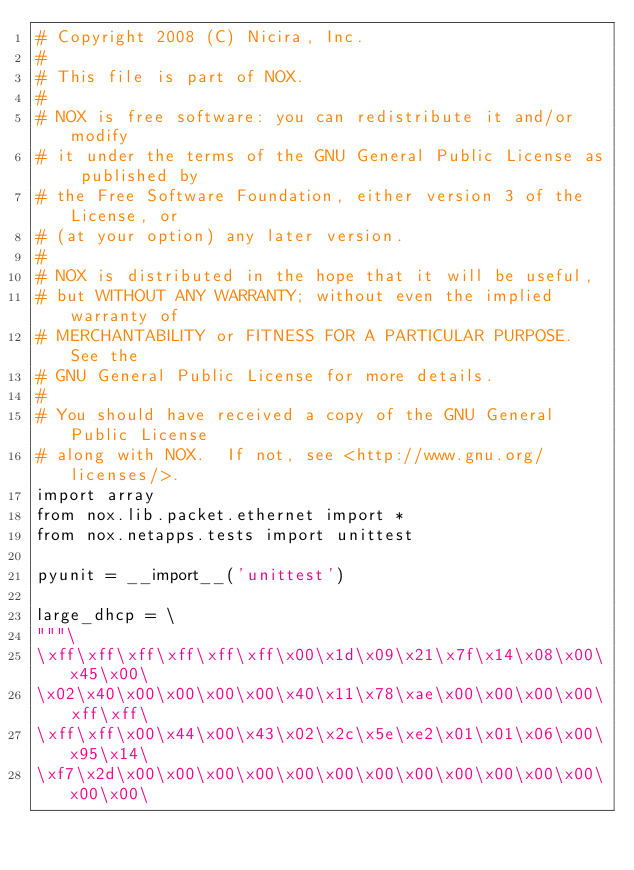Convert code to text. <code><loc_0><loc_0><loc_500><loc_500><_Python_># Copyright 2008 (C) Nicira, Inc.
# 
# This file is part of NOX.
# 
# NOX is free software: you can redistribute it and/or modify
# it under the terms of the GNU General Public License as published by
# the Free Software Foundation, either version 3 of the License, or
# (at your option) any later version.
# 
# NOX is distributed in the hope that it will be useful,
# but WITHOUT ANY WARRANTY; without even the implied warranty of
# MERCHANTABILITY or FITNESS FOR A PARTICULAR PURPOSE.  See the
# GNU General Public License for more details.
# 
# You should have received a copy of the GNU General Public License
# along with NOX.  If not, see <http://www.gnu.org/licenses/>.
import array
from nox.lib.packet.ethernet import *
from nox.netapps.tests import unittest

pyunit = __import__('unittest')

large_dhcp = \
"""\
\xff\xff\xff\xff\xff\xff\x00\x1d\x09\x21\x7f\x14\x08\x00\x45\x00\
\x02\x40\x00\x00\x00\x00\x40\x11\x78\xae\x00\x00\x00\x00\xff\xff\
\xff\xff\x00\x44\x00\x43\x02\x2c\x5e\xe2\x01\x01\x06\x00\x95\x14\
\xf7\x2d\x00\x00\x00\x00\x00\x00\x00\x00\x00\x00\x00\x00\x00\x00\</code> 